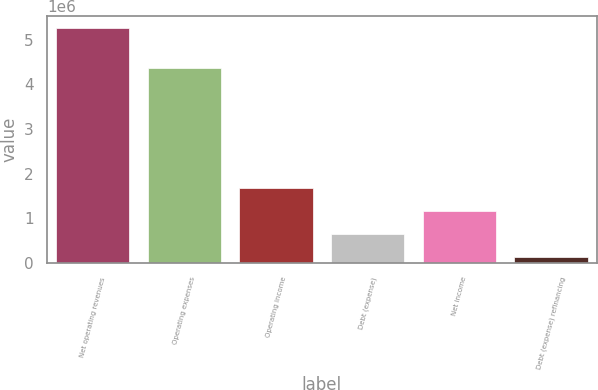Convert chart. <chart><loc_0><loc_0><loc_500><loc_500><bar_chart><fcel>Net operating revenues<fcel>Operating expenses<fcel>Operating income<fcel>Debt (expense)<fcel>Net income<fcel>Debt (expense) refinancing<nl><fcel>5.26415e+06<fcel>4.35646e+06<fcel>1.67949e+06<fcel>655302<fcel>1.1674e+06<fcel>143208<nl></chart> 